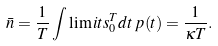Convert formula to latex. <formula><loc_0><loc_0><loc_500><loc_500>\bar { n } = \frac { 1 } { T } \int \lim i t s _ { 0 } ^ { T } d t \, p ( t ) = \frac { 1 } { \kappa T } .</formula> 